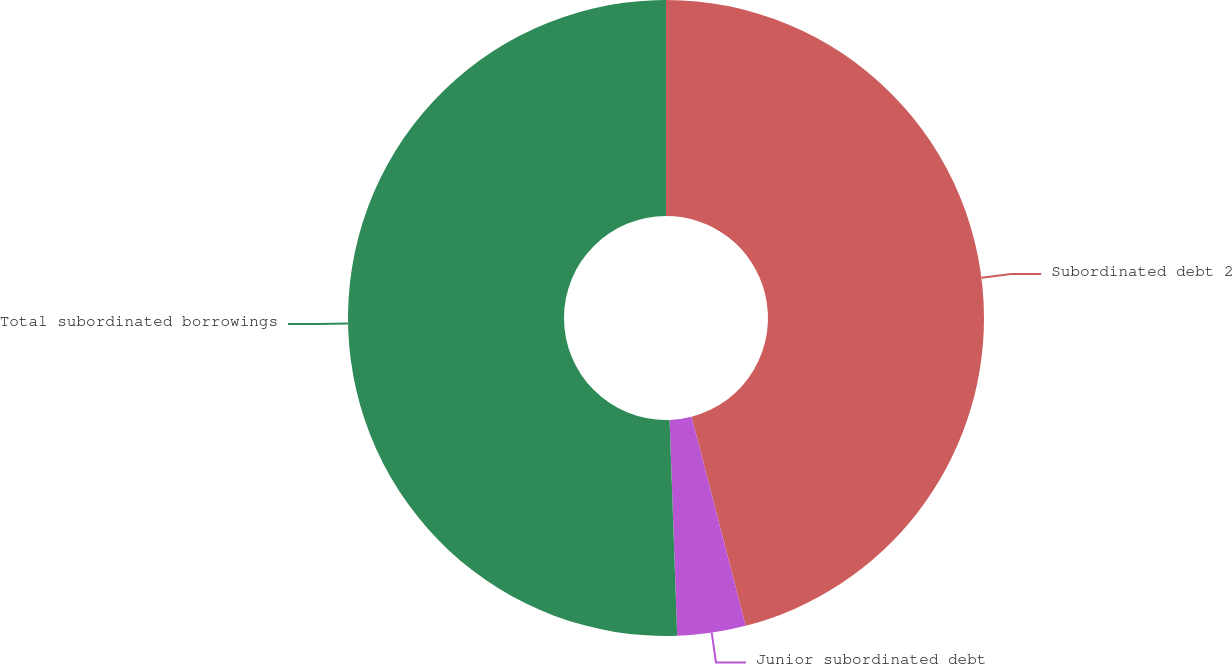Convert chart to OTSL. <chart><loc_0><loc_0><loc_500><loc_500><pie_chart><fcel>Subordinated debt 2<fcel>Junior subordinated debt<fcel>Total subordinated borrowings<nl><fcel>45.97%<fcel>3.47%<fcel>50.56%<nl></chart> 